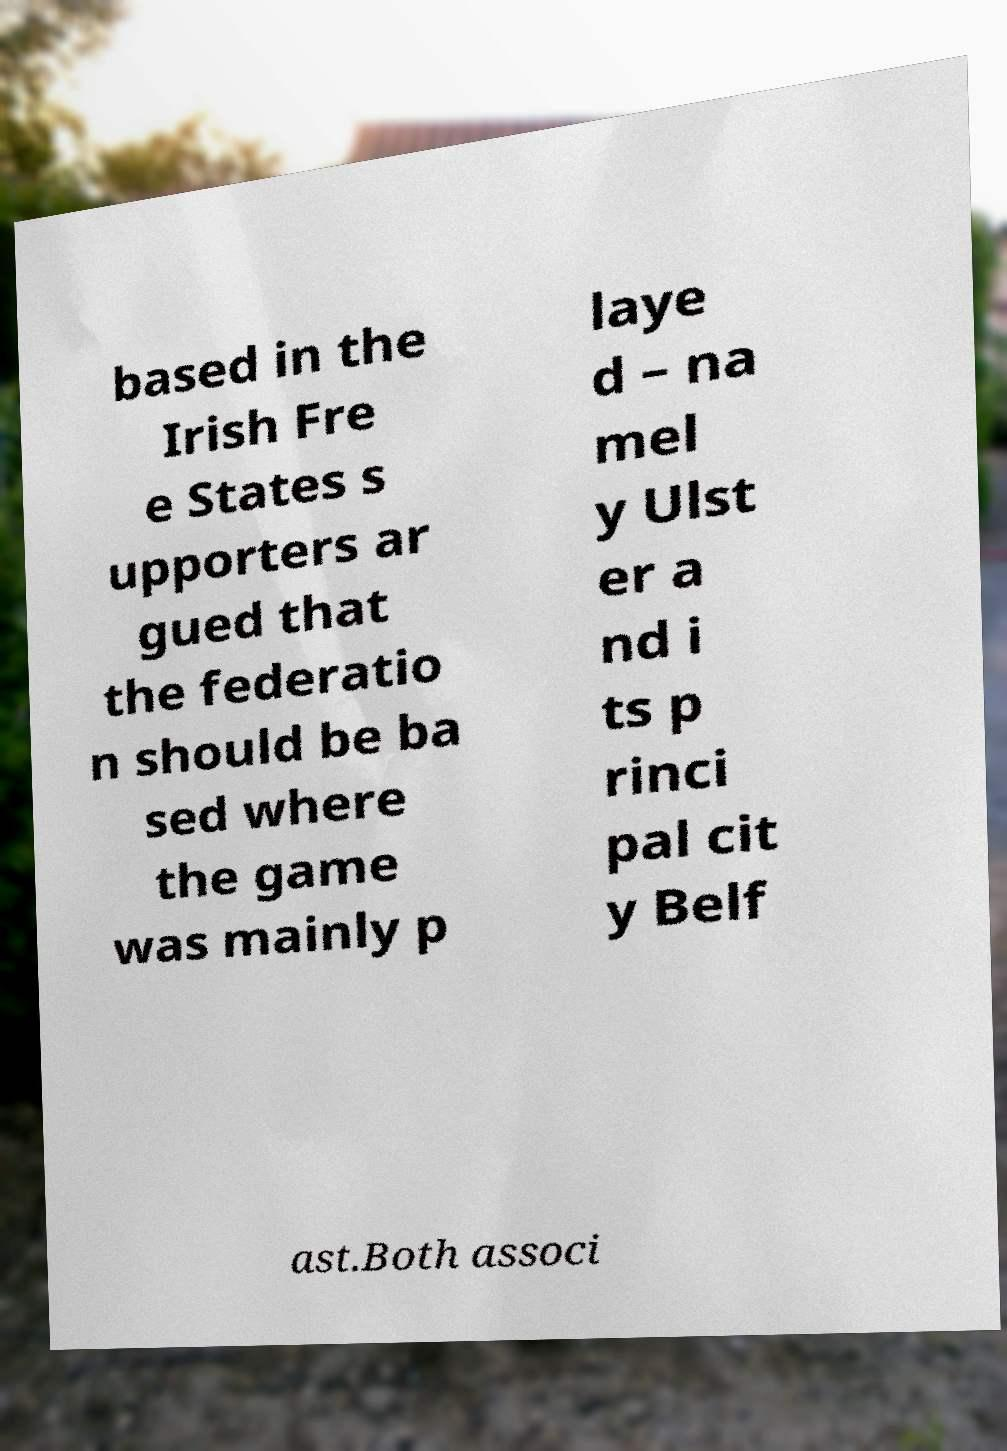Please identify and transcribe the text found in this image. based in the Irish Fre e States s upporters ar gued that the federatio n should be ba sed where the game was mainly p laye d – na mel y Ulst er a nd i ts p rinci pal cit y Belf ast.Both associ 